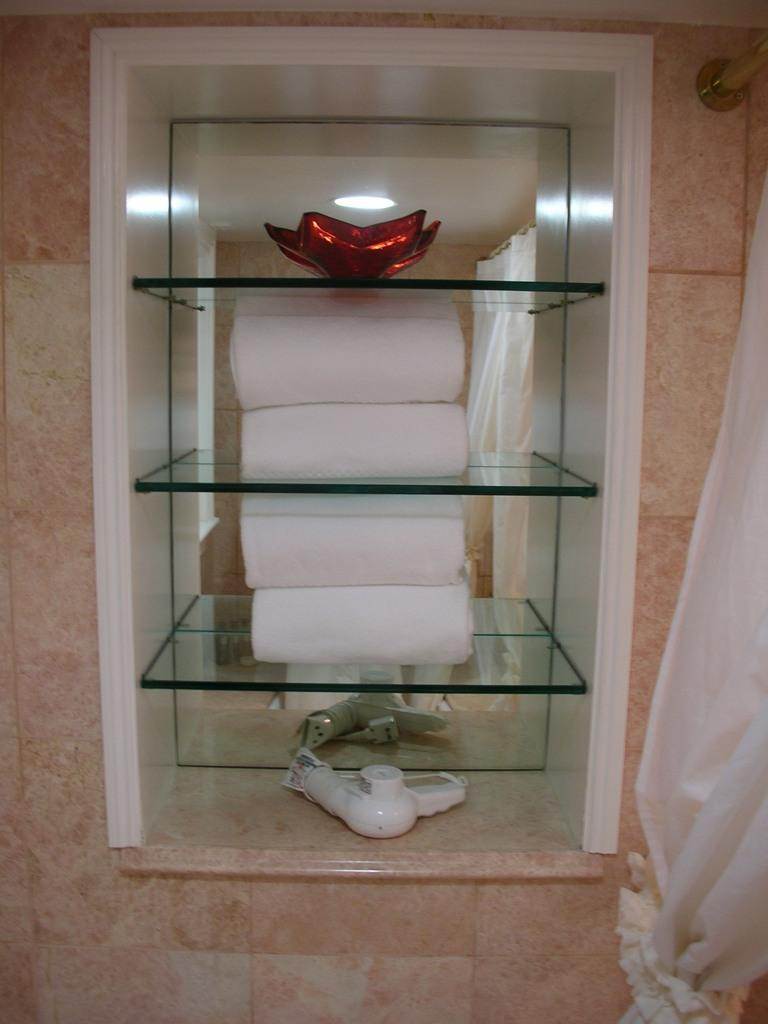What items can be seen in the shelves in the image? There are towels and other things in the shelves. What is located on the right side of the image? There is a metal rod on the right side of the image. What is associated with the metal rod? There is a curtain associated with the metal rod. How many boats are visible in the image? There are no boats present in the image. What is the chance of winning a self-driving car in the image? There is no reference to a self-driving car or any chances of winning in the image. 